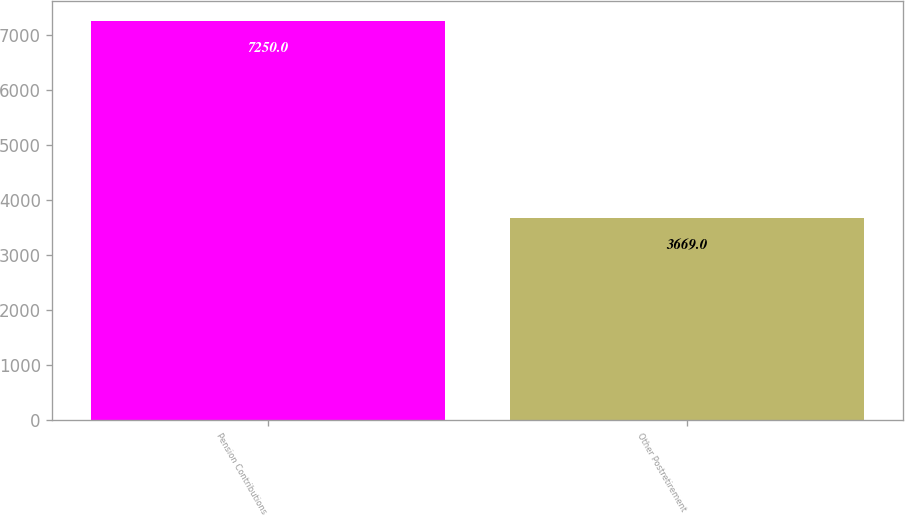Convert chart to OTSL. <chart><loc_0><loc_0><loc_500><loc_500><bar_chart><fcel>Pension Contributions<fcel>Other Postretirement<nl><fcel>7250<fcel>3669<nl></chart> 